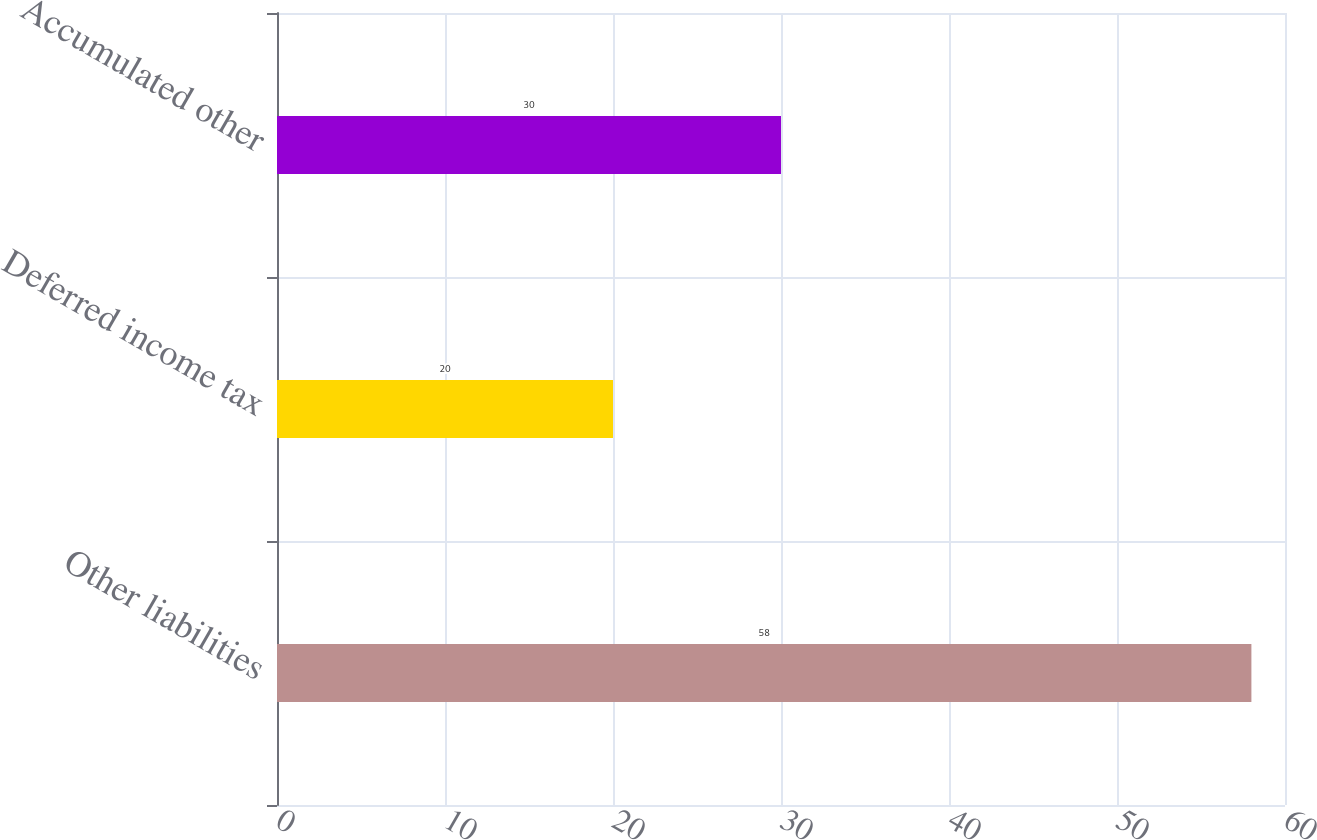Convert chart to OTSL. <chart><loc_0><loc_0><loc_500><loc_500><bar_chart><fcel>Other liabilities<fcel>Deferred income tax<fcel>Accumulated other<nl><fcel>58<fcel>20<fcel>30<nl></chart> 